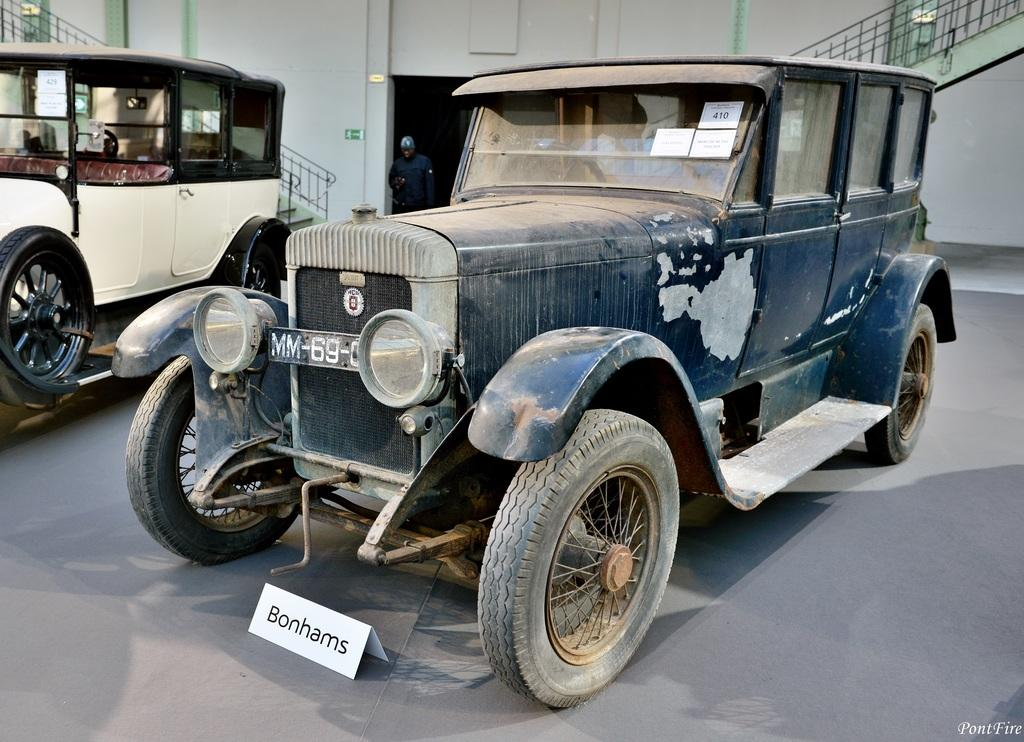How many vehicles can be seen on the road in the image? There are two vehicles visible on the road in the image. What type of structure is visible at the top of the image? There is a building visible at the top of the image. Can you describe any architectural features in the image? Yes, there is a staircase visible in the image. Who or what else can be seen in the image? A person is visible in the image. What part of the building is visible in the image? There is a wall of the building visible in the image. What type of root is growing through the net in the image? There is no root or net present in the image. What statement does the person in the image make? The image does not show the person making a statement, so it cannot be determined from the image. 